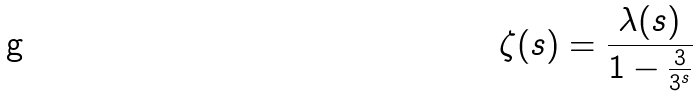<formula> <loc_0><loc_0><loc_500><loc_500>\zeta ( s ) = \frac { \lambda ( s ) } { 1 - \frac { 3 } { 3 ^ { s } } }</formula> 